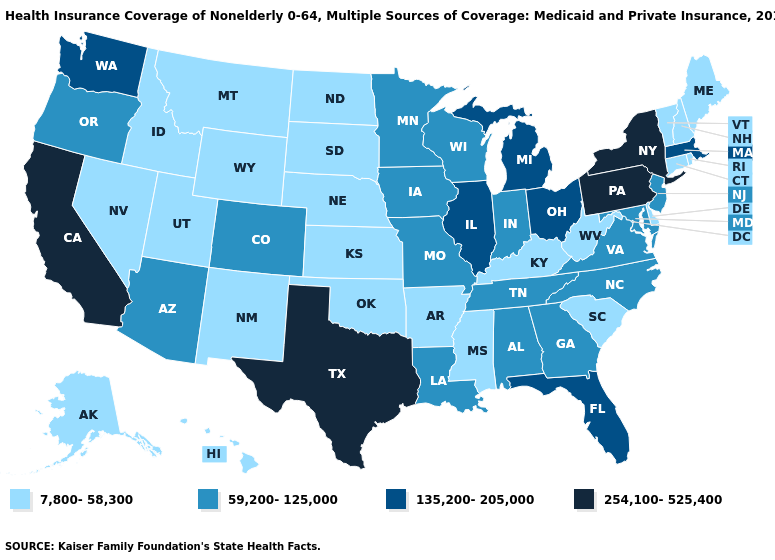Among the states that border New York , does Pennsylvania have the highest value?
Write a very short answer. Yes. Is the legend a continuous bar?
Give a very brief answer. No. How many symbols are there in the legend?
Keep it brief. 4. Name the states that have a value in the range 135,200-205,000?
Write a very short answer. Florida, Illinois, Massachusetts, Michigan, Ohio, Washington. Which states have the highest value in the USA?
Keep it brief. California, New York, Pennsylvania, Texas. What is the value of New Mexico?
Give a very brief answer. 7,800-58,300. Among the states that border Oregon , does California have the highest value?
Write a very short answer. Yes. Does Massachusetts have the highest value in the USA?
Quick response, please. No. What is the value of Alaska?
Write a very short answer. 7,800-58,300. Which states have the highest value in the USA?
Give a very brief answer. California, New York, Pennsylvania, Texas. Name the states that have a value in the range 59,200-125,000?
Quick response, please. Alabama, Arizona, Colorado, Georgia, Indiana, Iowa, Louisiana, Maryland, Minnesota, Missouri, New Jersey, North Carolina, Oregon, Tennessee, Virginia, Wisconsin. What is the lowest value in states that border Missouri?
Give a very brief answer. 7,800-58,300. Name the states that have a value in the range 254,100-525,400?
Keep it brief. California, New York, Pennsylvania, Texas. Which states have the lowest value in the USA?
Write a very short answer. Alaska, Arkansas, Connecticut, Delaware, Hawaii, Idaho, Kansas, Kentucky, Maine, Mississippi, Montana, Nebraska, Nevada, New Hampshire, New Mexico, North Dakota, Oklahoma, Rhode Island, South Carolina, South Dakota, Utah, Vermont, West Virginia, Wyoming. 